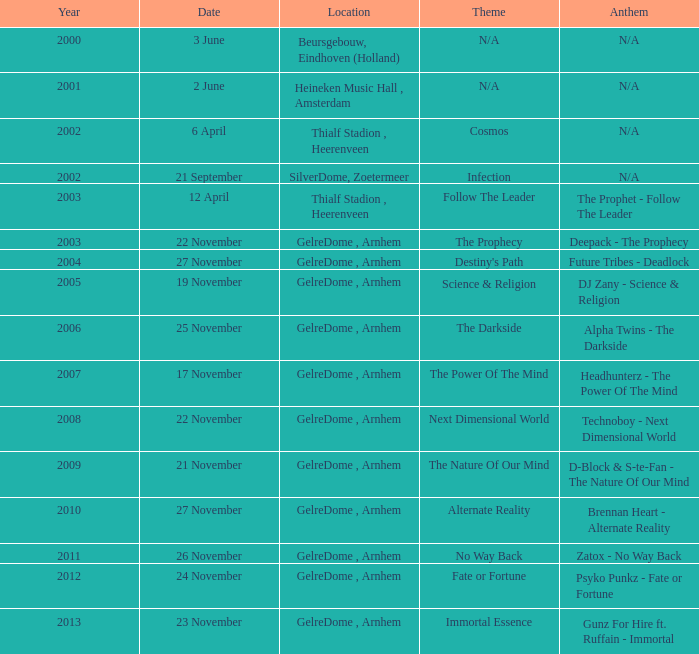What is the earliest year it was located in gelredome, arnhem, and a Anthem of technoboy - next dimensional world? 2008.0. 